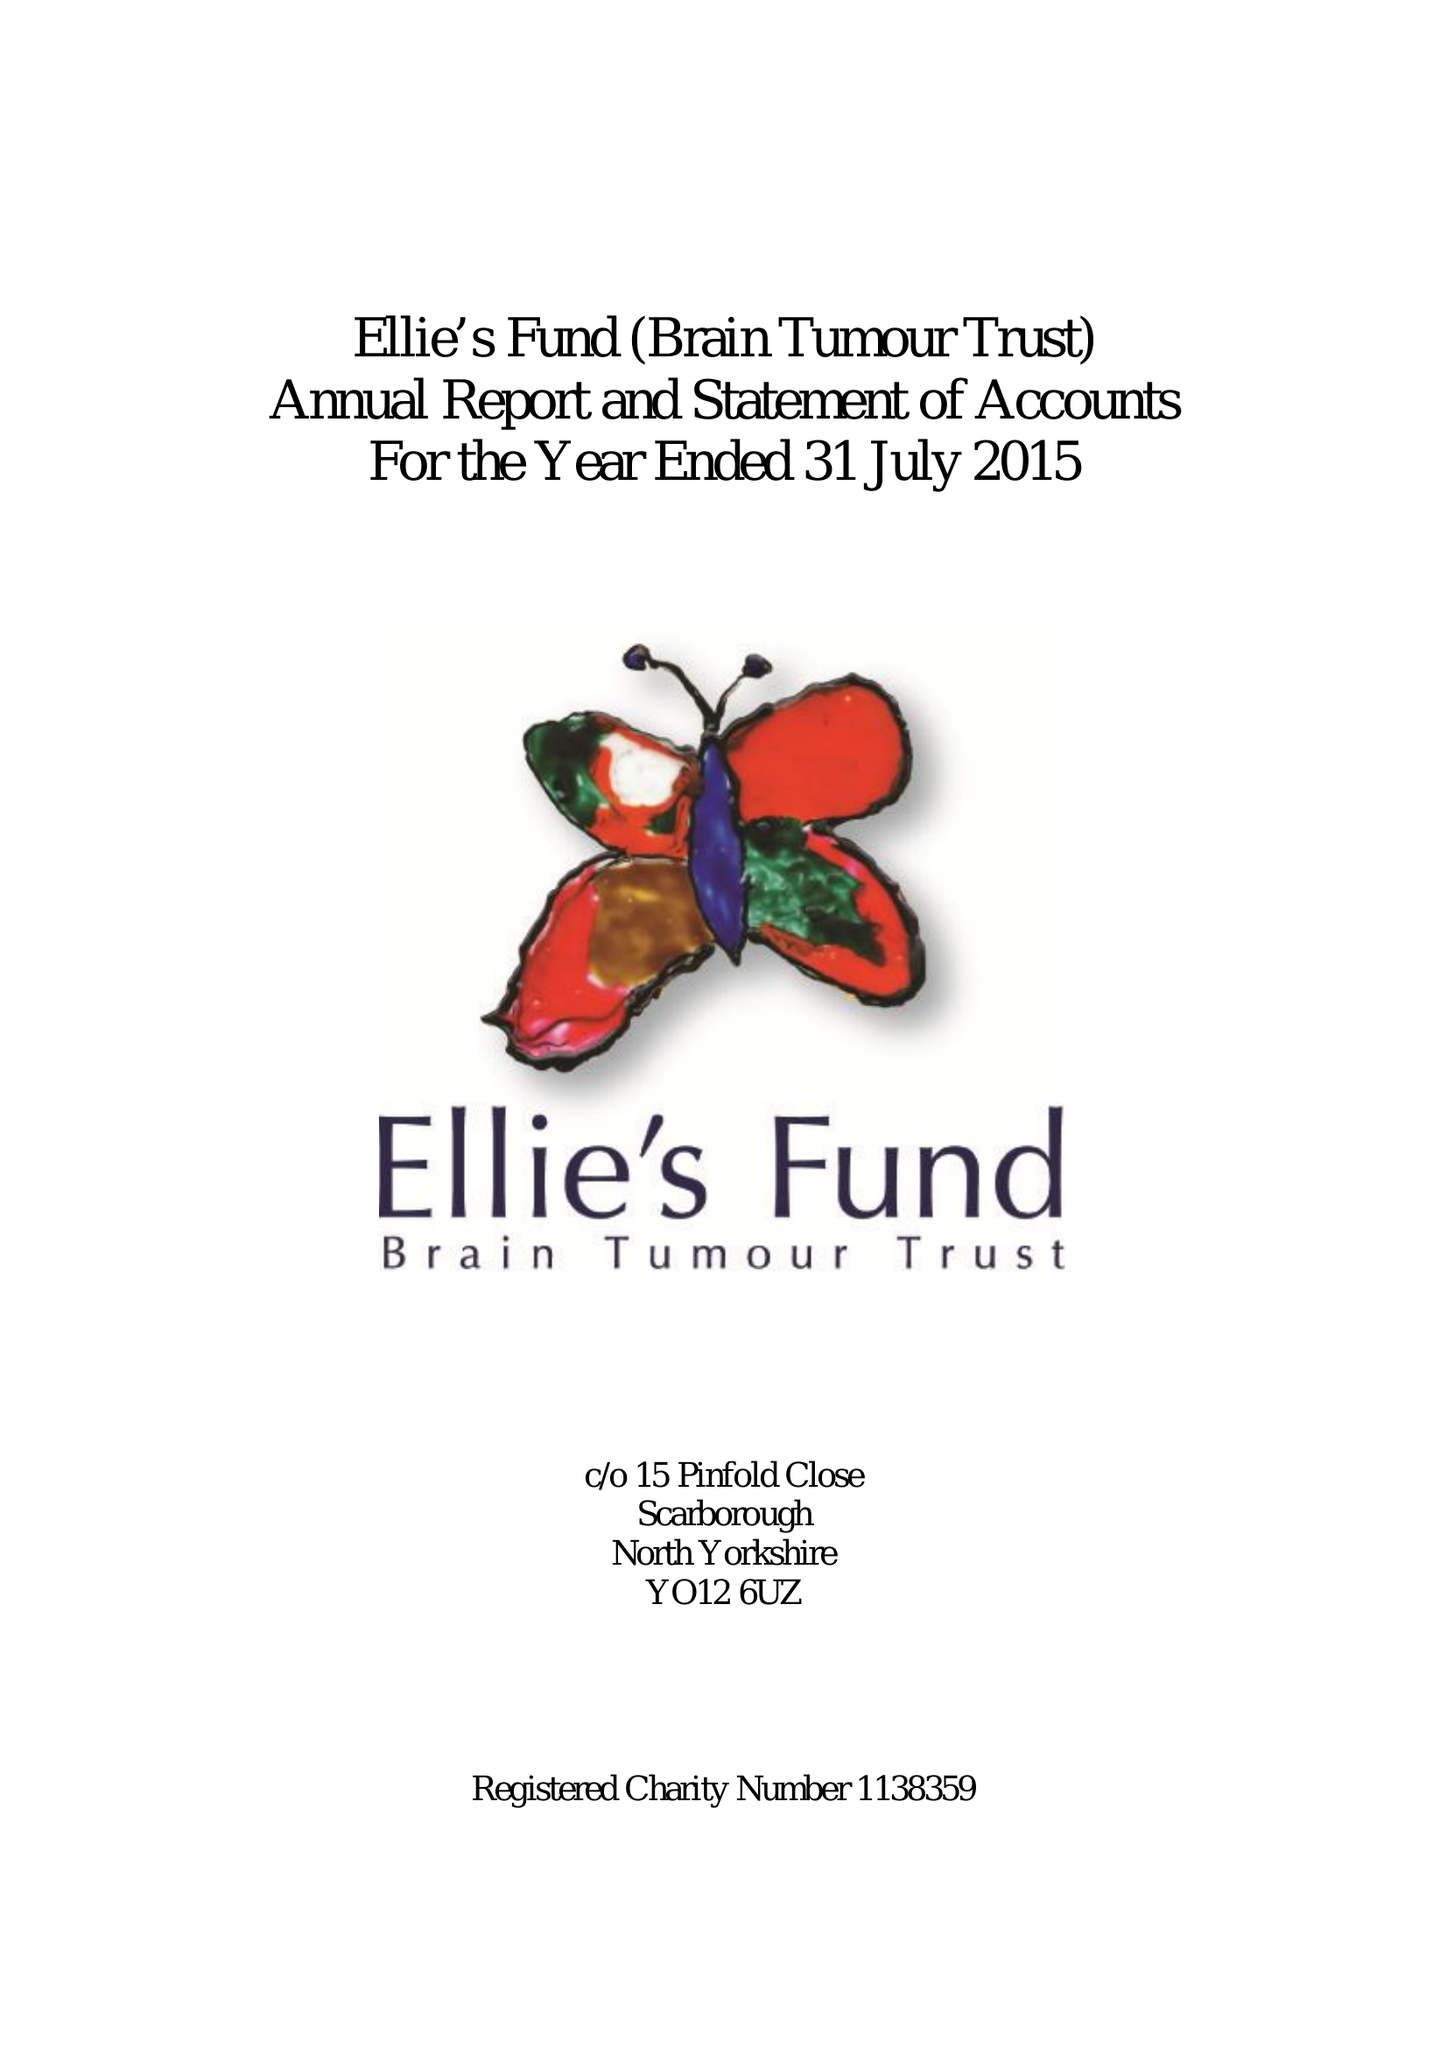What is the value for the address__street_line?
Answer the question using a single word or phrase. None 